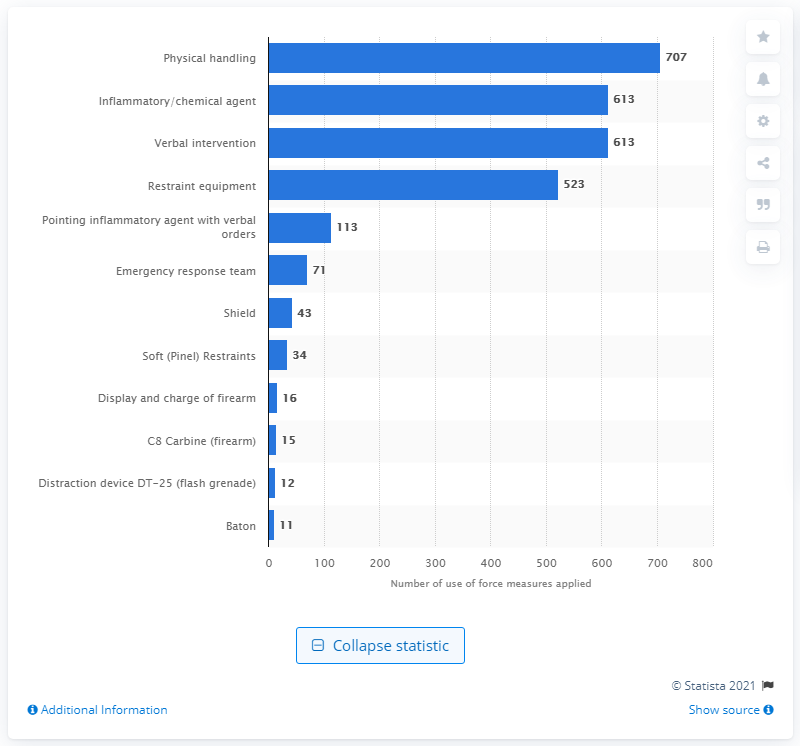Point out several critical features in this image. There were 11 incidents of the use of force with a baton in federal prisons in fiscal year 2020. There were 707 physical handling incidents in federal prisons during fiscal year 2020. 